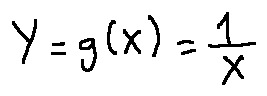Convert formula to latex. <formula><loc_0><loc_0><loc_500><loc_500>Y = g ( X ) = \frac { 1 } { X }</formula> 